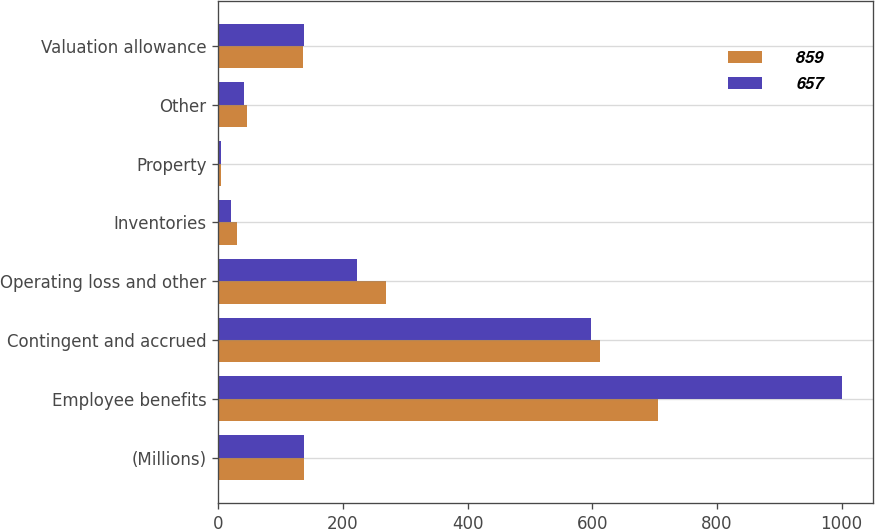Convert chart to OTSL. <chart><loc_0><loc_0><loc_500><loc_500><stacked_bar_chart><ecel><fcel>(Millions)<fcel>Employee benefits<fcel>Contingent and accrued<fcel>Operating loss and other<fcel>Inventories<fcel>Property<fcel>Other<fcel>Valuation allowance<nl><fcel>859<fcel>137<fcel>706<fcel>613<fcel>269<fcel>31<fcel>4<fcel>47<fcel>136<nl><fcel>657<fcel>137<fcel>1000<fcel>598<fcel>223<fcel>21<fcel>5<fcel>41<fcel>138<nl></chart> 